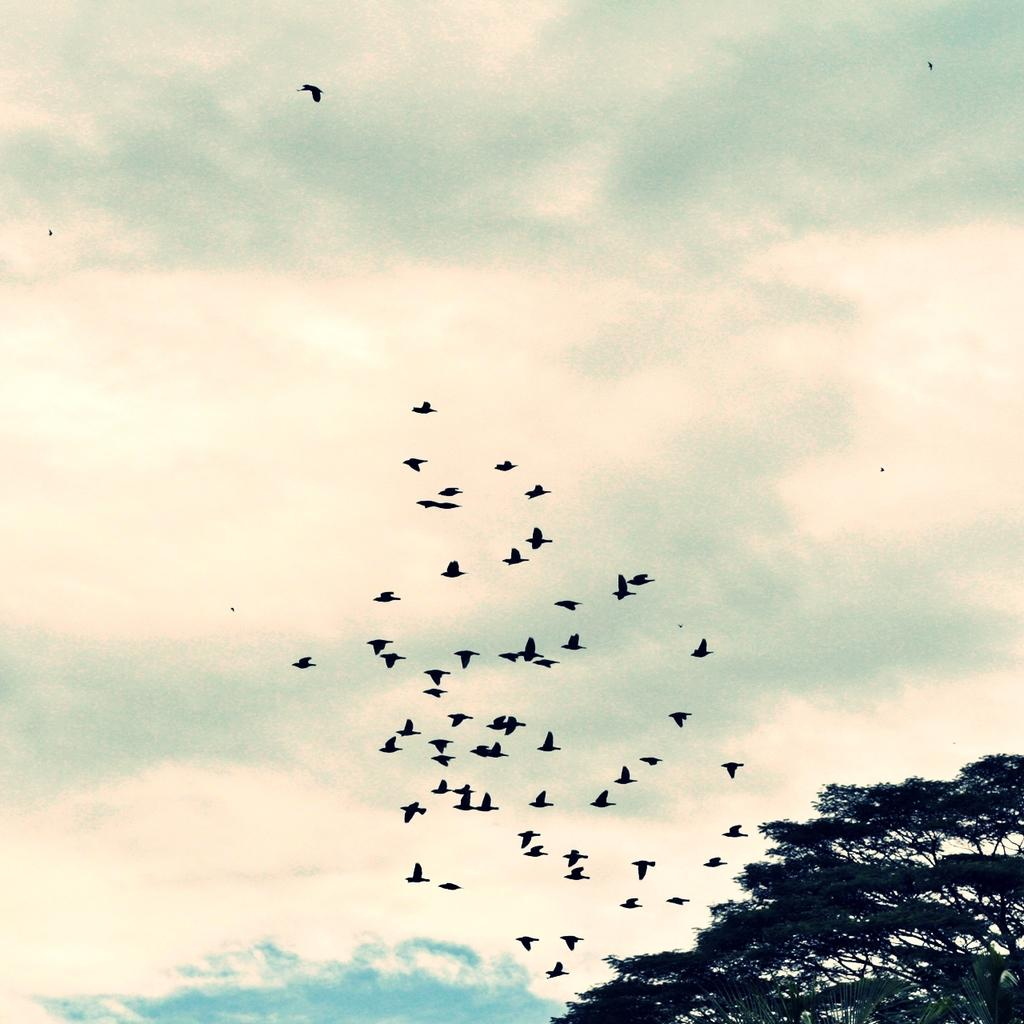What is happening in the sky in the image? There are birds flying in the air in the image. What type of vegetation can be seen in the image? There are trees visible in the image. What is visible in the background of the image? The sky is visible in the background of the image. Where is the crayon located in the image? There is no crayon present in the image. What type of animal can be seen walking in the image? There are no animals visible in the image, let alone walking. 